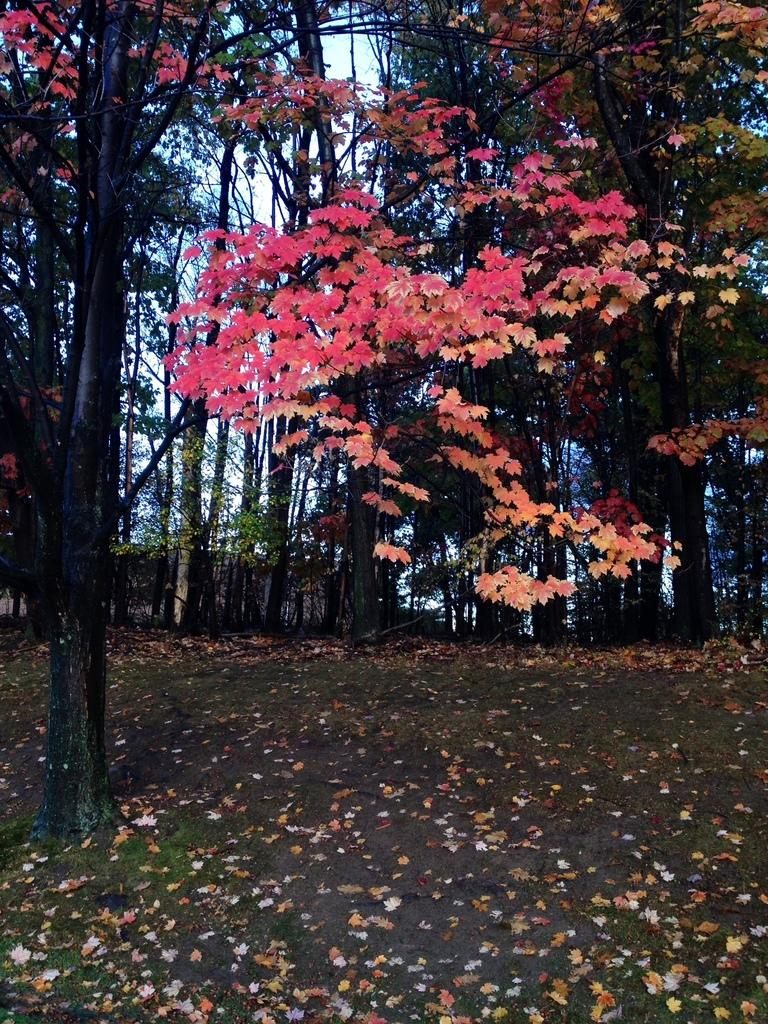What is on the ground in the image? There are leaves on the ground in the image. What type of vegetation is present in the image? There are trees in the image. What colors can be seen on the trees in the image? The trees have various colors, including green, pink, orange, and black. What can be seen in the background of the image? The sky is visible in the background of the image. How many ducks are sitting on the ball in the image? There are no ducks or ball present in the image. What type of shock is depicted in the image? There is no shock depicted in the image; it features trees with various colors and leaves on the ground. 